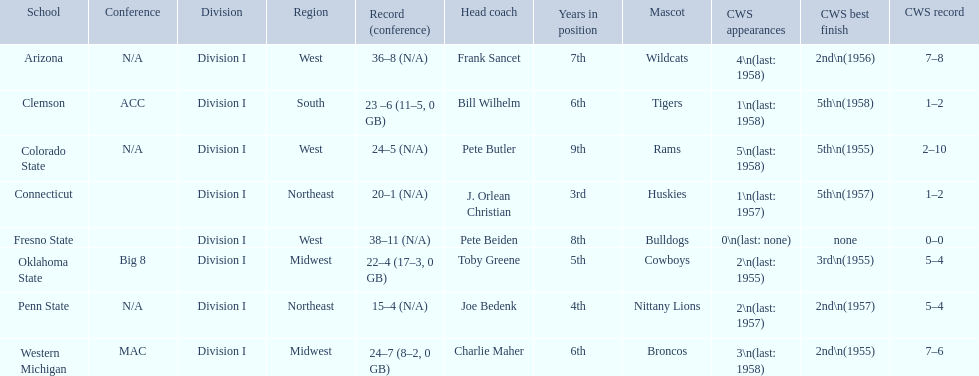What are the listed schools? Arizona, Clemson, Colorado State, Connecticut, Fresno State, Oklahoma State, Penn State, Western Michigan. Which are clemson and western michigan? Clemson, Western Michigan. What are their corresponding numbers of cws appearances? 1\n(last: 1958), 3\n(last: 1958). Which value is larger? 3\n(last: 1958). To which school does that value belong to? Western Michigan. 